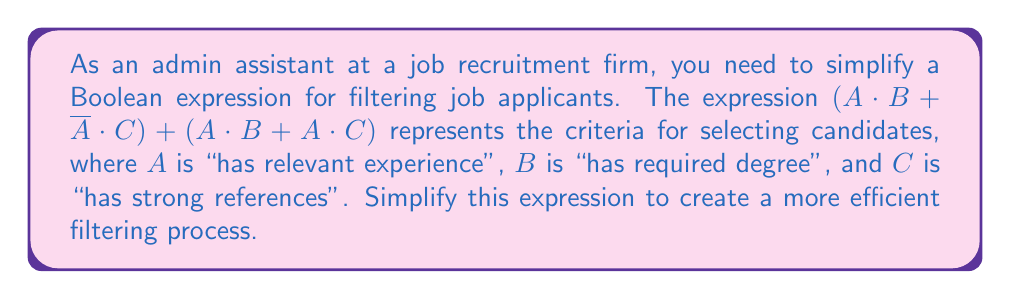Can you answer this question? Let's simplify the expression step by step:

1. Start with the given expression:
   $$(A \cdot B + \overline{A} \cdot C) + (A \cdot B + A \cdot C)$$

2. Apply the distributive property to factor out $A \cdot B$:
   $$A \cdot B + (\overline{A} \cdot C + A \cdot C)$$

3. In the second term, we can factor out $C$:
   $$A \cdot B + C \cdot (\overline{A} + A)$$

4. The term $(\overline{A} + A)$ is always true (law of excluded middle), so it simplifies to 1:
   $$A \cdot B + C \cdot 1$$

5. Simplify further:
   $$A \cdot B + C$$

This simplified expression means that a candidate will be selected if they have relevant experience AND the required degree, OR if they have strong references.
Answer: $A \cdot B + C$ 